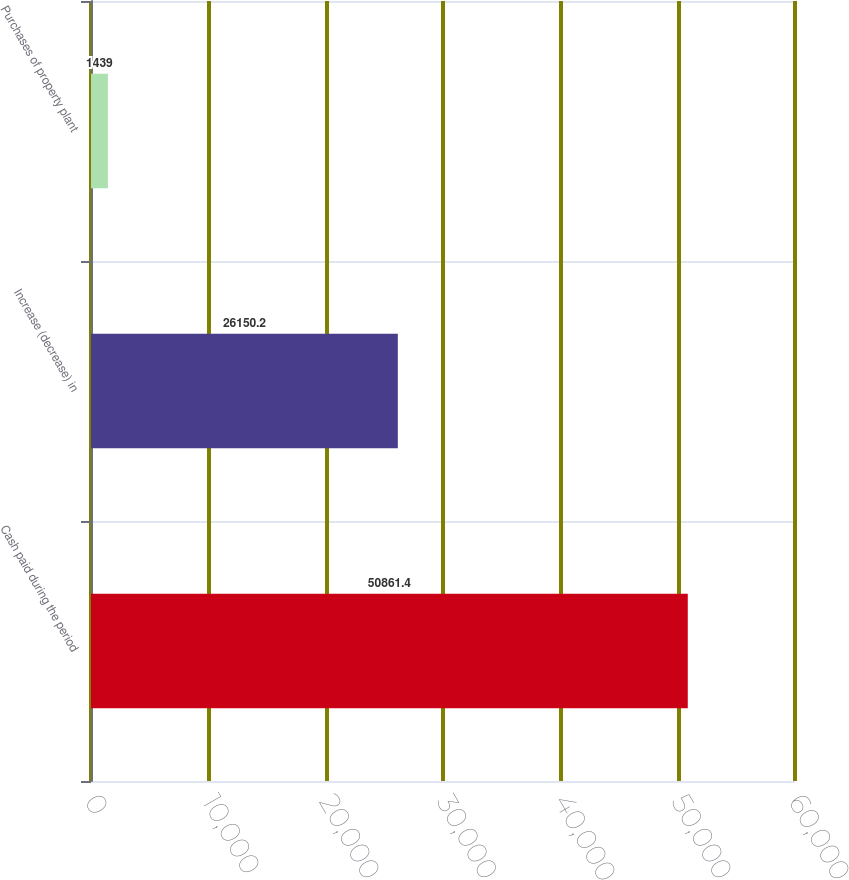Convert chart to OTSL. <chart><loc_0><loc_0><loc_500><loc_500><bar_chart><fcel>Cash paid during the period<fcel>Increase (decrease) in<fcel>Purchases of property plant<nl><fcel>50861.4<fcel>26150.2<fcel>1439<nl></chart> 